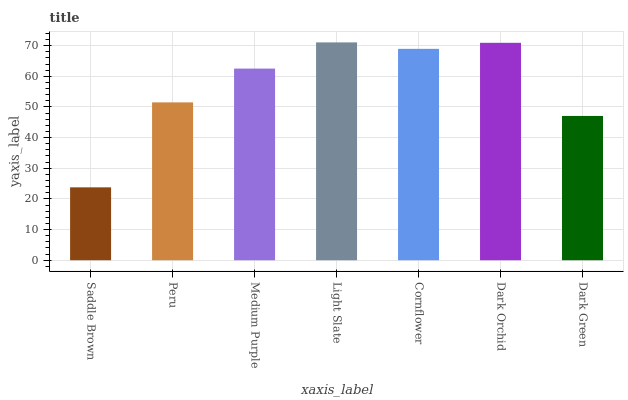Is Saddle Brown the minimum?
Answer yes or no. Yes. Is Light Slate the maximum?
Answer yes or no. Yes. Is Peru the minimum?
Answer yes or no. No. Is Peru the maximum?
Answer yes or no. No. Is Peru greater than Saddle Brown?
Answer yes or no. Yes. Is Saddle Brown less than Peru?
Answer yes or no. Yes. Is Saddle Brown greater than Peru?
Answer yes or no. No. Is Peru less than Saddle Brown?
Answer yes or no. No. Is Medium Purple the high median?
Answer yes or no. Yes. Is Medium Purple the low median?
Answer yes or no. Yes. Is Peru the high median?
Answer yes or no. No. Is Dark Green the low median?
Answer yes or no. No. 